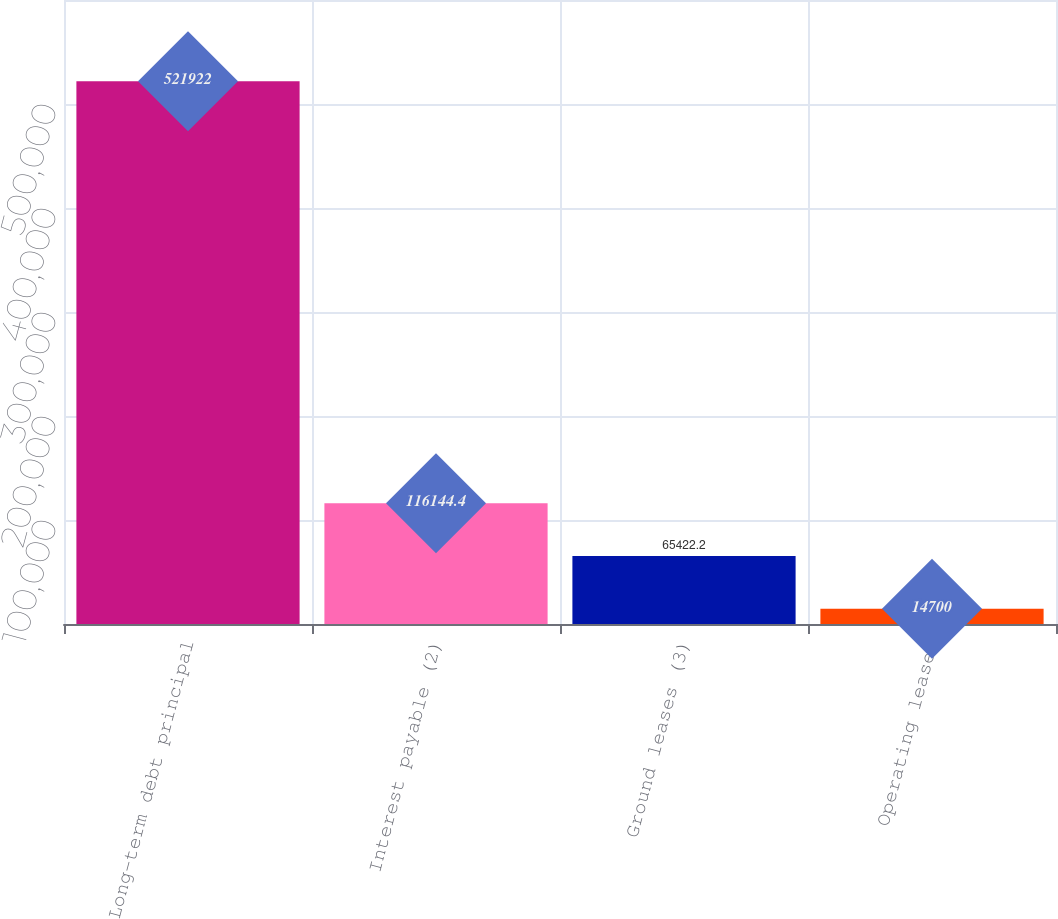Convert chart to OTSL. <chart><loc_0><loc_0><loc_500><loc_500><bar_chart><fcel>Long-term debt principal<fcel>Interest payable (2)<fcel>Ground leases (3)<fcel>Operating leases<nl><fcel>521922<fcel>116144<fcel>65422.2<fcel>14700<nl></chart> 